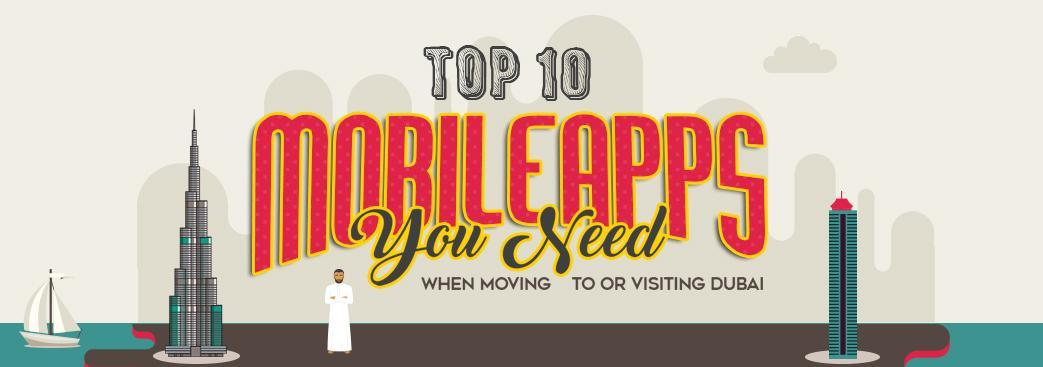what is the man in the picture wearing, thawb or suit
Answer the question with a short phrase. thawb Which is the tallest building shown, burj khalifa or burj al arab burj khalifa 